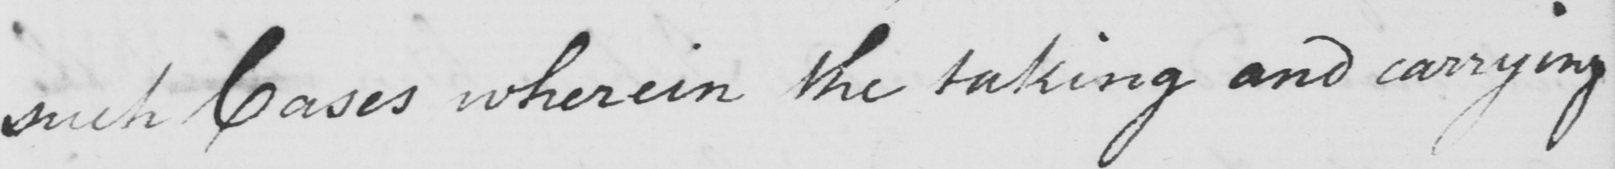Please transcribe the handwritten text in this image. such Cases wherein the taking and carrying 